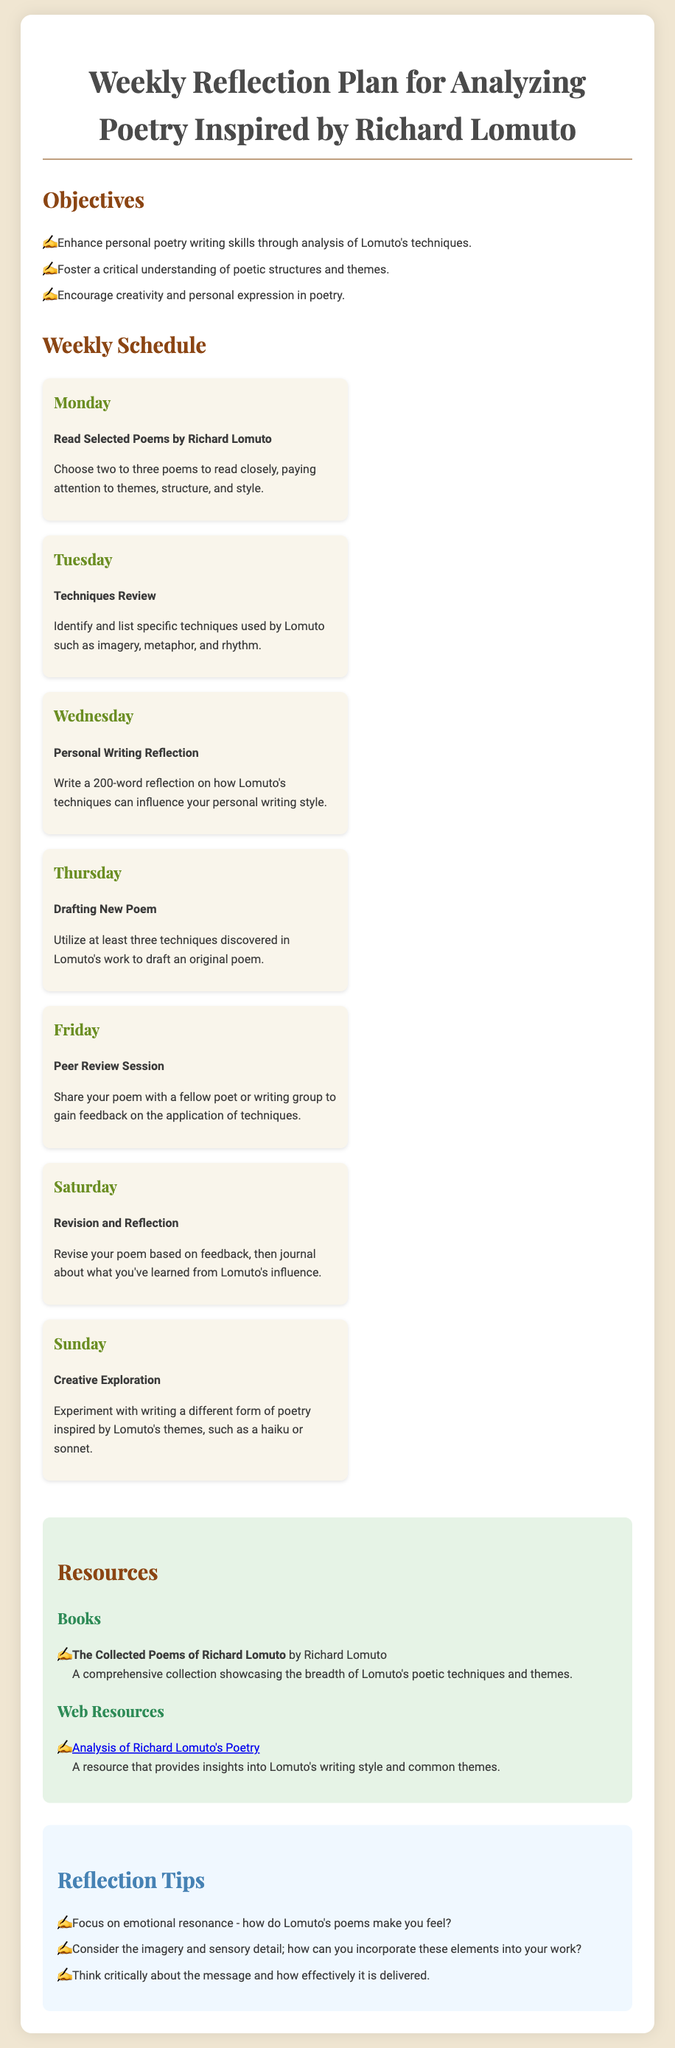What is the title of the document? The title is mentioned at the beginning of the document as the main heading.
Answer: Weekly Reflection Plan for Analyzing Poetry Inspired by Richard Lomuto What day is dedicated to reading selected poems by Richard Lomuto? The specific day is listed in the weekly schedule section under the respective heading.
Answer: Monday Which poetic techniques should be reviewed on Tuesday? The document indicates a focus on identifying specific techniques in the scheduled activities for Tuesday.
Answer: Imagery, metaphor, and rhythm How many words should be written in the personal writing reflection on Wednesday? The word count for the reflection is specified in the activities outlined for Wednesday.
Answer: 200 words What type of writing session is scheduled for Friday? The nature of the session is described in the weekly schedule for Friday, where sharing takes place.
Answer: Peer Review Session What is the main objective of the weekly reflection plan? The main objective is detailed at the beginning of the document, under the objectives heading.
Answer: Enhance personal poetry writing skills through analysis of Lomuto's techniques Which day is focused on creative exploration? The specific day is detailed in the daily schedule within the document.
Answer: Sunday What is the title of Richard Lomuto's collected works mentioned in the resources section? The title of the book is found in the resources section under the books heading.
Answer: The Collected Poems of Richard Lomuto What is one reflection tip mentioned in the document? Reflection tips are listed under their specific section in the document.
Answer: Focus on emotional resonance - how do Lomuto's poems make you feel? 